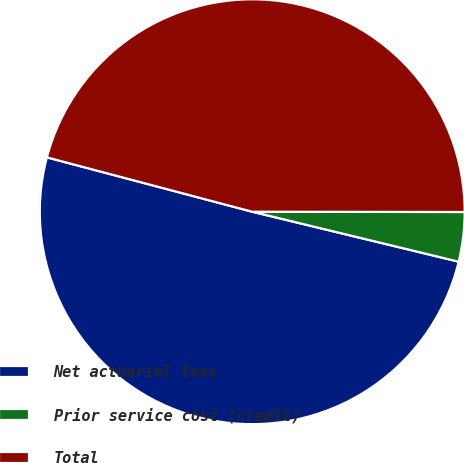<chart> <loc_0><loc_0><loc_500><loc_500><pie_chart><fcel>Net actuarial loss<fcel>Prior service cost (credit)<fcel>Total<nl><fcel>50.34%<fcel>3.76%<fcel>45.9%<nl></chart> 